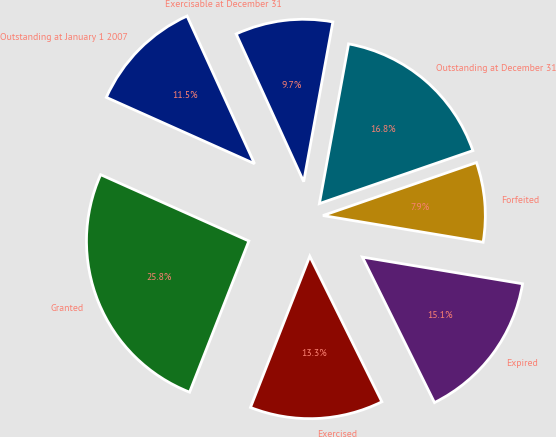Convert chart to OTSL. <chart><loc_0><loc_0><loc_500><loc_500><pie_chart><fcel>Outstanding at January 1 2007<fcel>Granted<fcel>Exercised<fcel>Expired<fcel>Forfeited<fcel>Outstanding at December 31<fcel>Exercisable at December 31<nl><fcel>11.48%<fcel>25.75%<fcel>13.27%<fcel>15.05%<fcel>7.92%<fcel>16.83%<fcel>9.7%<nl></chart> 